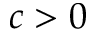<formula> <loc_0><loc_0><loc_500><loc_500>c > 0</formula> 